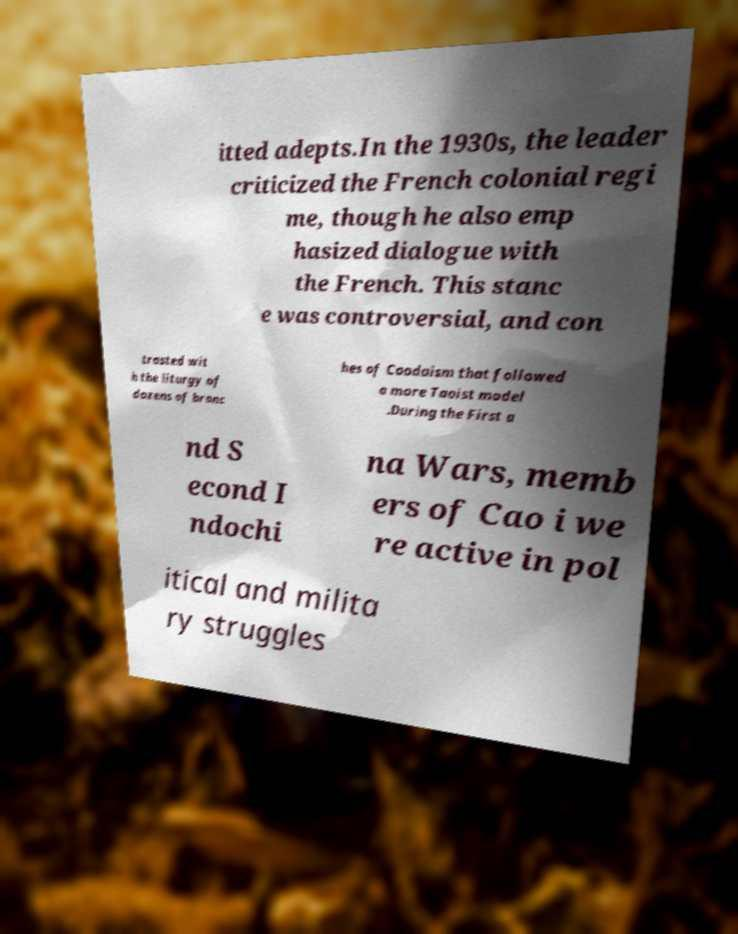What messages or text are displayed in this image? I need them in a readable, typed format. itted adepts.In the 1930s, the leader criticized the French colonial regi me, though he also emp hasized dialogue with the French. This stanc e was controversial, and con trasted wit h the liturgy of dozens of branc hes of Caodaism that followed a more Taoist model .During the First a nd S econd I ndochi na Wars, memb ers of Cao i we re active in pol itical and milita ry struggles 